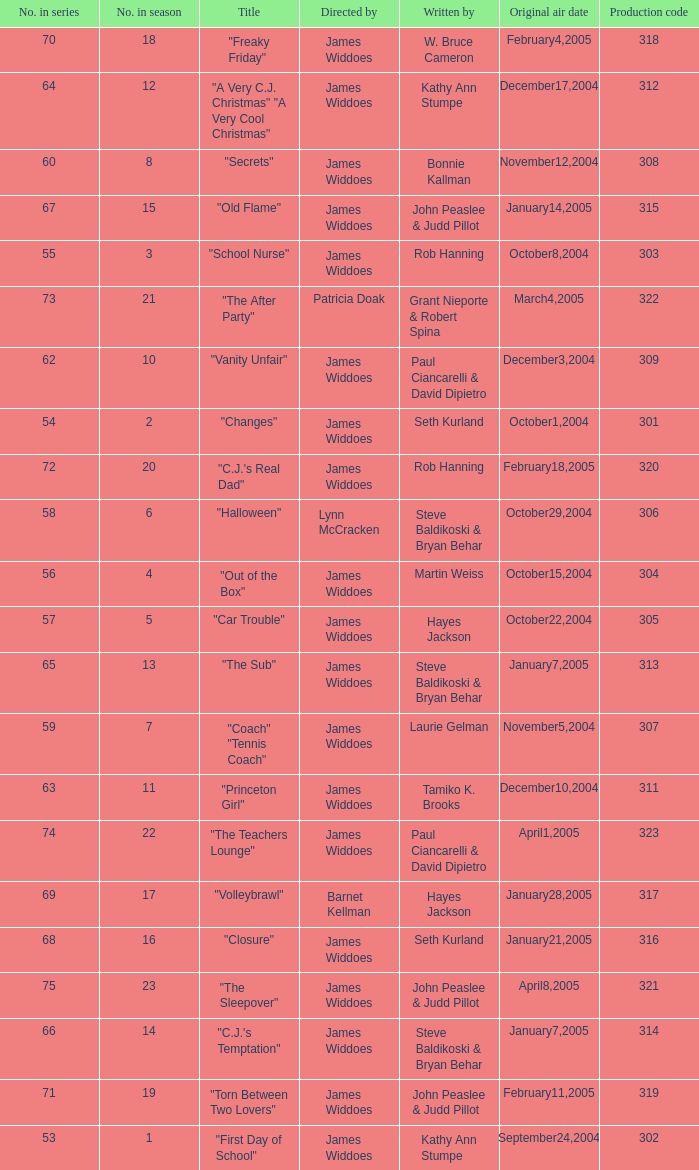What is the production code for episode 3 of the season? 303.0. 